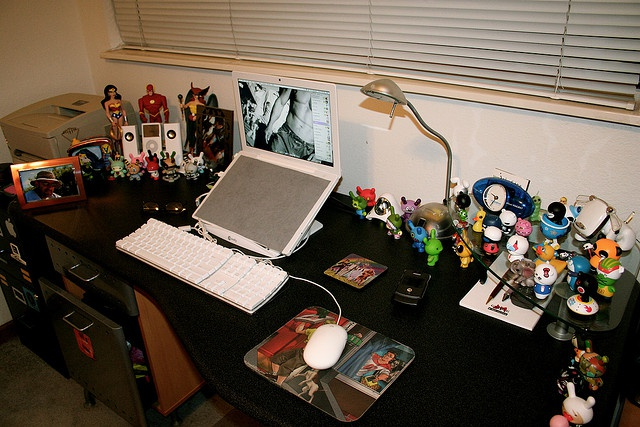Describe the objects in this image and their specific colors. I can see laptop in maroon, gray, lightgray, and darkgray tones, keyboard in maroon, lightgray, tan, and darkgray tones, book in maroon, lightgray, black, and darkgray tones, mouse in maroon, lightgray, tan, and darkgray tones, and cell phone in maroon, black, gray, and darkgray tones in this image. 